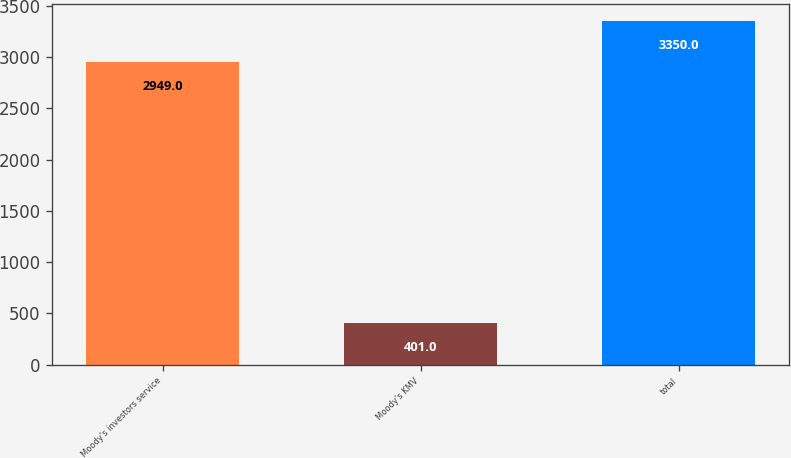Convert chart to OTSL. <chart><loc_0><loc_0><loc_500><loc_500><bar_chart><fcel>Moody's investors service<fcel>Moody's KMV<fcel>total<nl><fcel>2949<fcel>401<fcel>3350<nl></chart> 